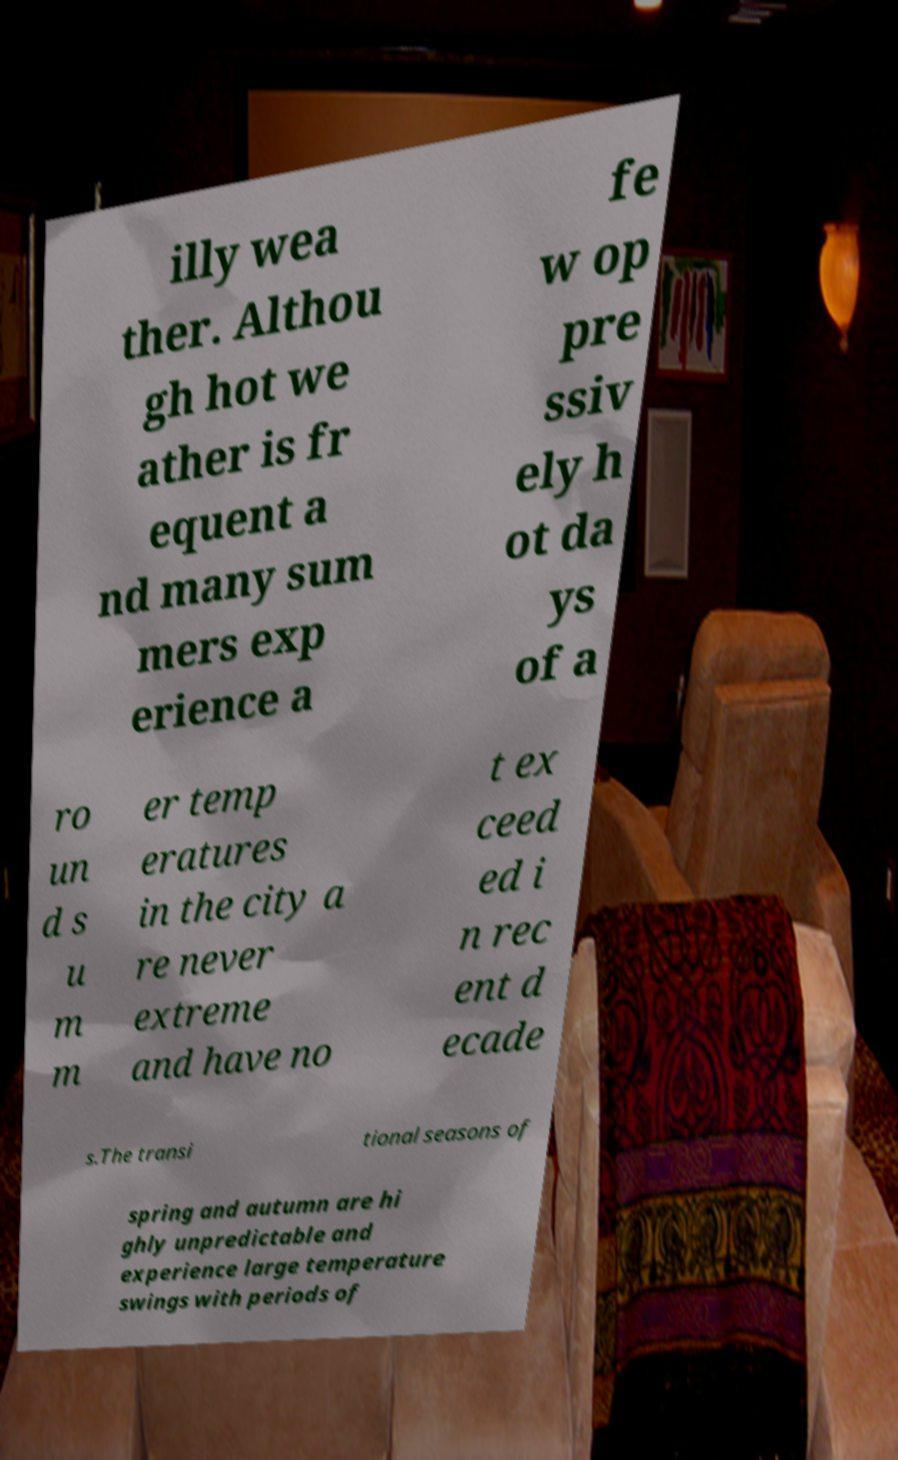Can you accurately transcribe the text from the provided image for me? illy wea ther. Althou gh hot we ather is fr equent a nd many sum mers exp erience a fe w op pre ssiv ely h ot da ys of a ro un d s u m m er temp eratures in the city a re never extreme and have no t ex ceed ed i n rec ent d ecade s.The transi tional seasons of spring and autumn are hi ghly unpredictable and experience large temperature swings with periods of 